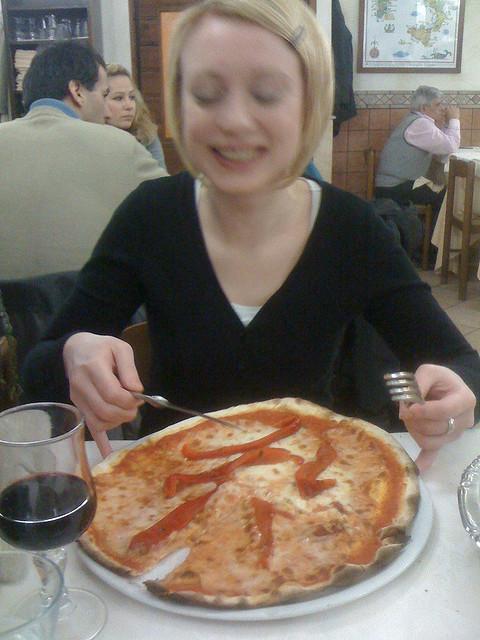How many different types of foods are there?
Give a very brief answer. 1. How many cups are on the girls right?
Give a very brief answer. 1. How many chairs are there?
Give a very brief answer. 2. How many people are there?
Give a very brief answer. 4. How many headlights does this truck have?
Give a very brief answer. 0. 